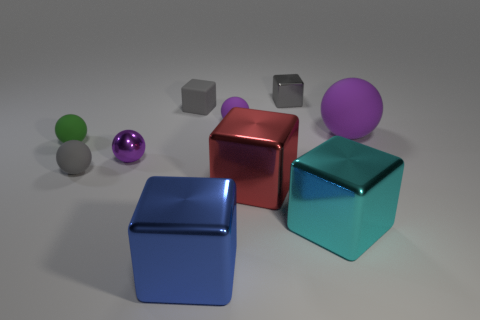If you had to guess, what material do the matte spheres look like they're made of? The matte spheres, comprising one green and one smaller purple sphere, give the impression of being made of a soft, non-reflective material, possibly something akin to velvet or rubber. This is based on their non-glossy finish and the way they absorb light, showing no clear highlights or reflections. 